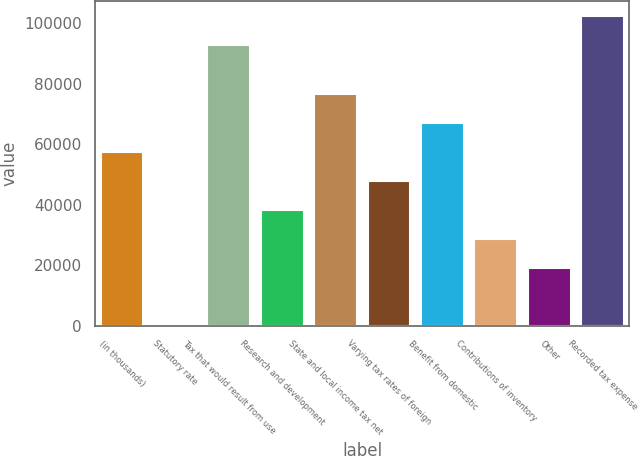<chart> <loc_0><loc_0><loc_500><loc_500><bar_chart><fcel>(in thousands)<fcel>Statutory rate<fcel>Tax that would result from use<fcel>Research and development<fcel>State and local income tax net<fcel>Varying tax rates of foreign<fcel>Benefit from domestic<fcel>Contributions of inventory<fcel>Other<fcel>Recorded tax expense<nl><fcel>57554<fcel>35<fcel>92726<fcel>38381<fcel>76727<fcel>47967.5<fcel>67140.5<fcel>28794.5<fcel>19208<fcel>102312<nl></chart> 